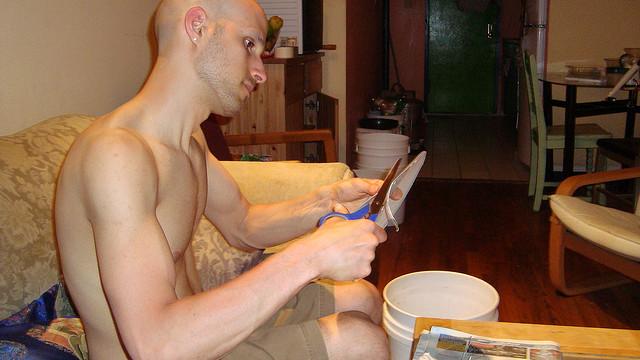What kind of decor is on the arm of the couch?
Keep it brief. Pillow. Is the guy a sheep shearer?
Quick response, please. No. What receptacle is next to the man's leg?
Write a very short answer. Bucket. What is he doing?
Write a very short answer. Cutting paper. Is he wearing a shirt?
Short answer required. No. 